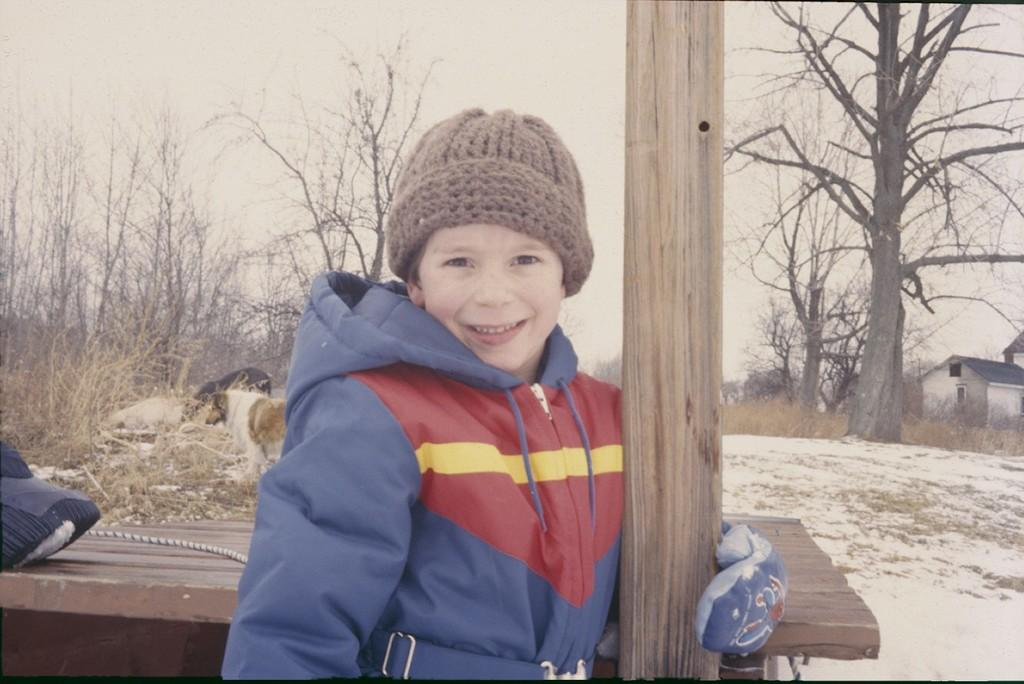What is located in the foreground of the image? There is a boy, a table, and dogs in the foreground of the image. What can be seen in the background of the image? There are trees, houses, and the sky visible in the background of the image. What is the time of day when the image was likely taken? The image was likely taken during the day, as the sky is visible. What type of story is being told by the oven in the image? There is no oven present in the image, so no story can be told by an oven. What is the current temperature of the dogs in the image? The temperature of the dogs cannot be determined from the image, as it does not provide any information about the temperature. 